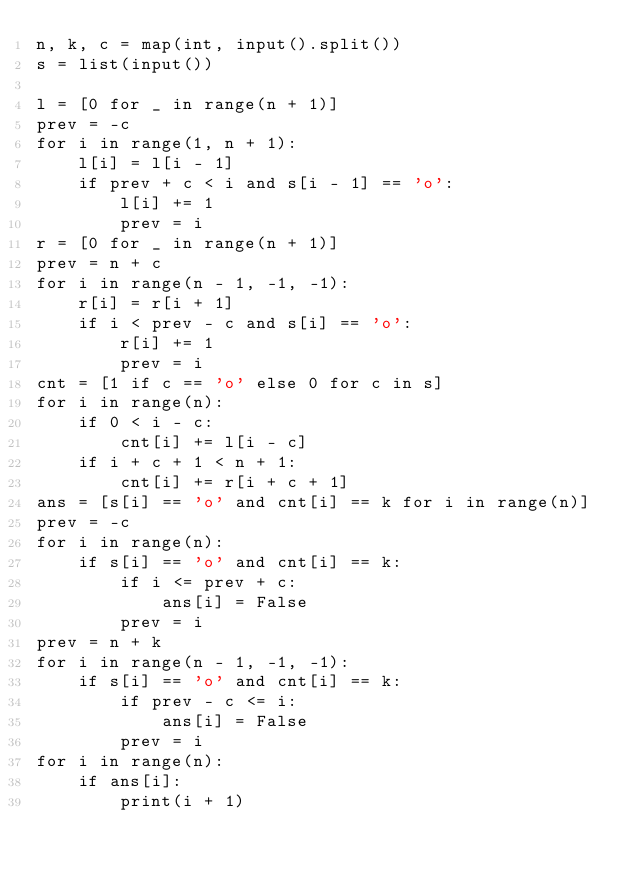<code> <loc_0><loc_0><loc_500><loc_500><_Python_>n, k, c = map(int, input().split())
s = list(input())

l = [0 for _ in range(n + 1)]
prev = -c
for i in range(1, n + 1):
    l[i] = l[i - 1]
    if prev + c < i and s[i - 1] == 'o':
        l[i] += 1
        prev = i
r = [0 for _ in range(n + 1)]
prev = n + c
for i in range(n - 1, -1, -1):
    r[i] = r[i + 1]
    if i < prev - c and s[i] == 'o':
        r[i] += 1
        prev = i
cnt = [1 if c == 'o' else 0 for c in s]
for i in range(n):
    if 0 < i - c:
        cnt[i] += l[i - c]
    if i + c + 1 < n + 1:
        cnt[i] += r[i + c + 1]
ans = [s[i] == 'o' and cnt[i] == k for i in range(n)]
prev = -c
for i in range(n):
    if s[i] == 'o' and cnt[i] == k:
        if i <= prev + c:
            ans[i] = False
        prev = i
prev = n + k
for i in range(n - 1, -1, -1):
    if s[i] == 'o' and cnt[i] == k:
        if prev - c <= i:
            ans[i] = False
        prev = i
for i in range(n):
    if ans[i]:
        print(i + 1)</code> 